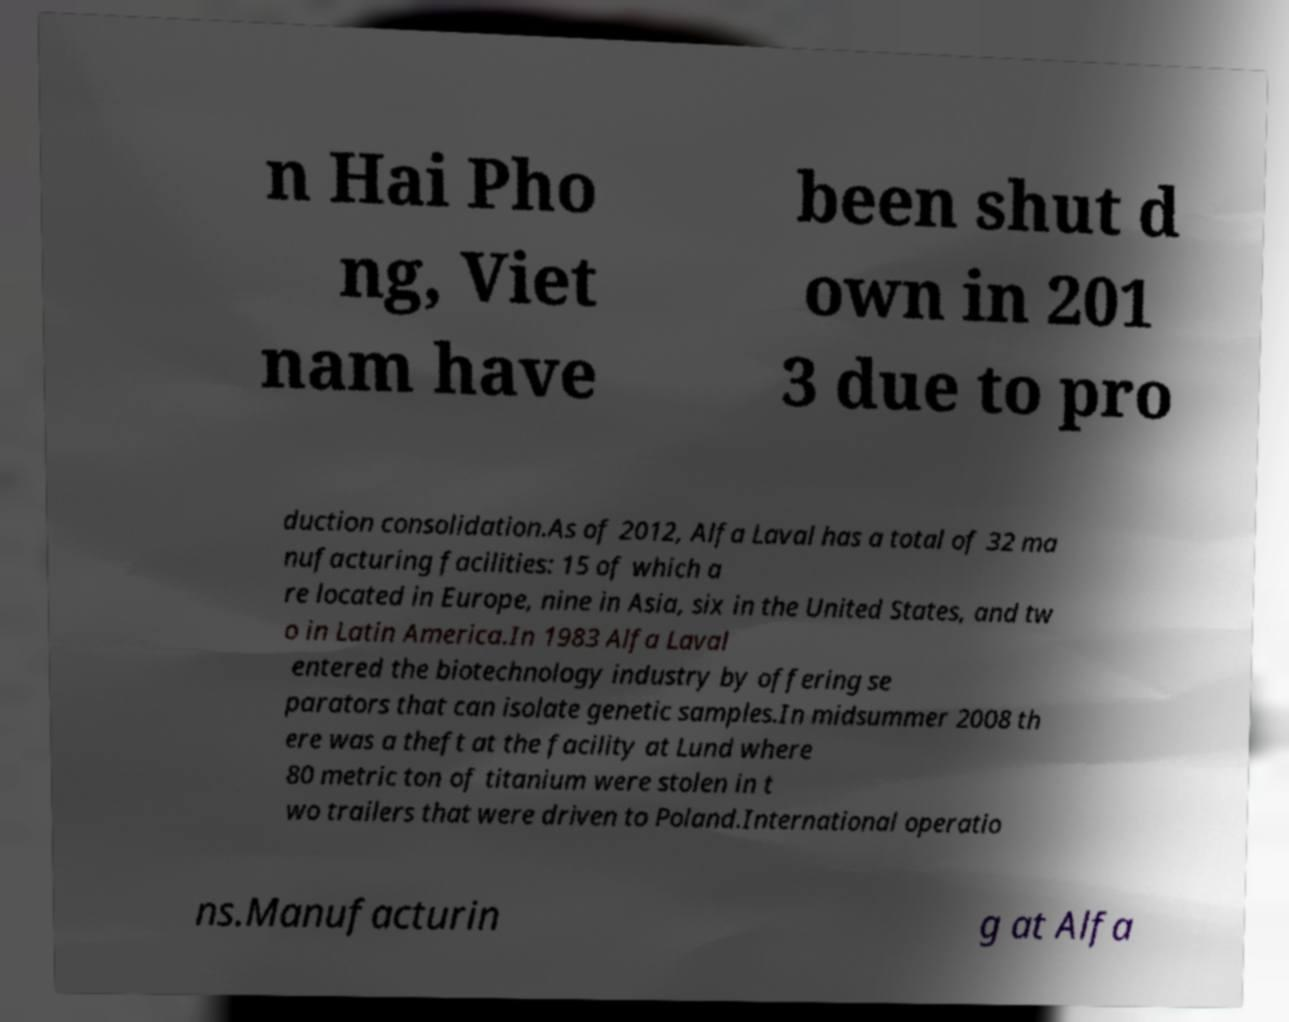Could you extract and type out the text from this image? n Hai Pho ng, Viet nam have been shut d own in 201 3 due to pro duction consolidation.As of 2012, Alfa Laval has a total of 32 ma nufacturing facilities: 15 of which a re located in Europe, nine in Asia, six in the United States, and tw o in Latin America.In 1983 Alfa Laval entered the biotechnology industry by offering se parators that can isolate genetic samples.In midsummer 2008 th ere was a theft at the facility at Lund where 80 metric ton of titanium were stolen in t wo trailers that were driven to Poland.International operatio ns.Manufacturin g at Alfa 